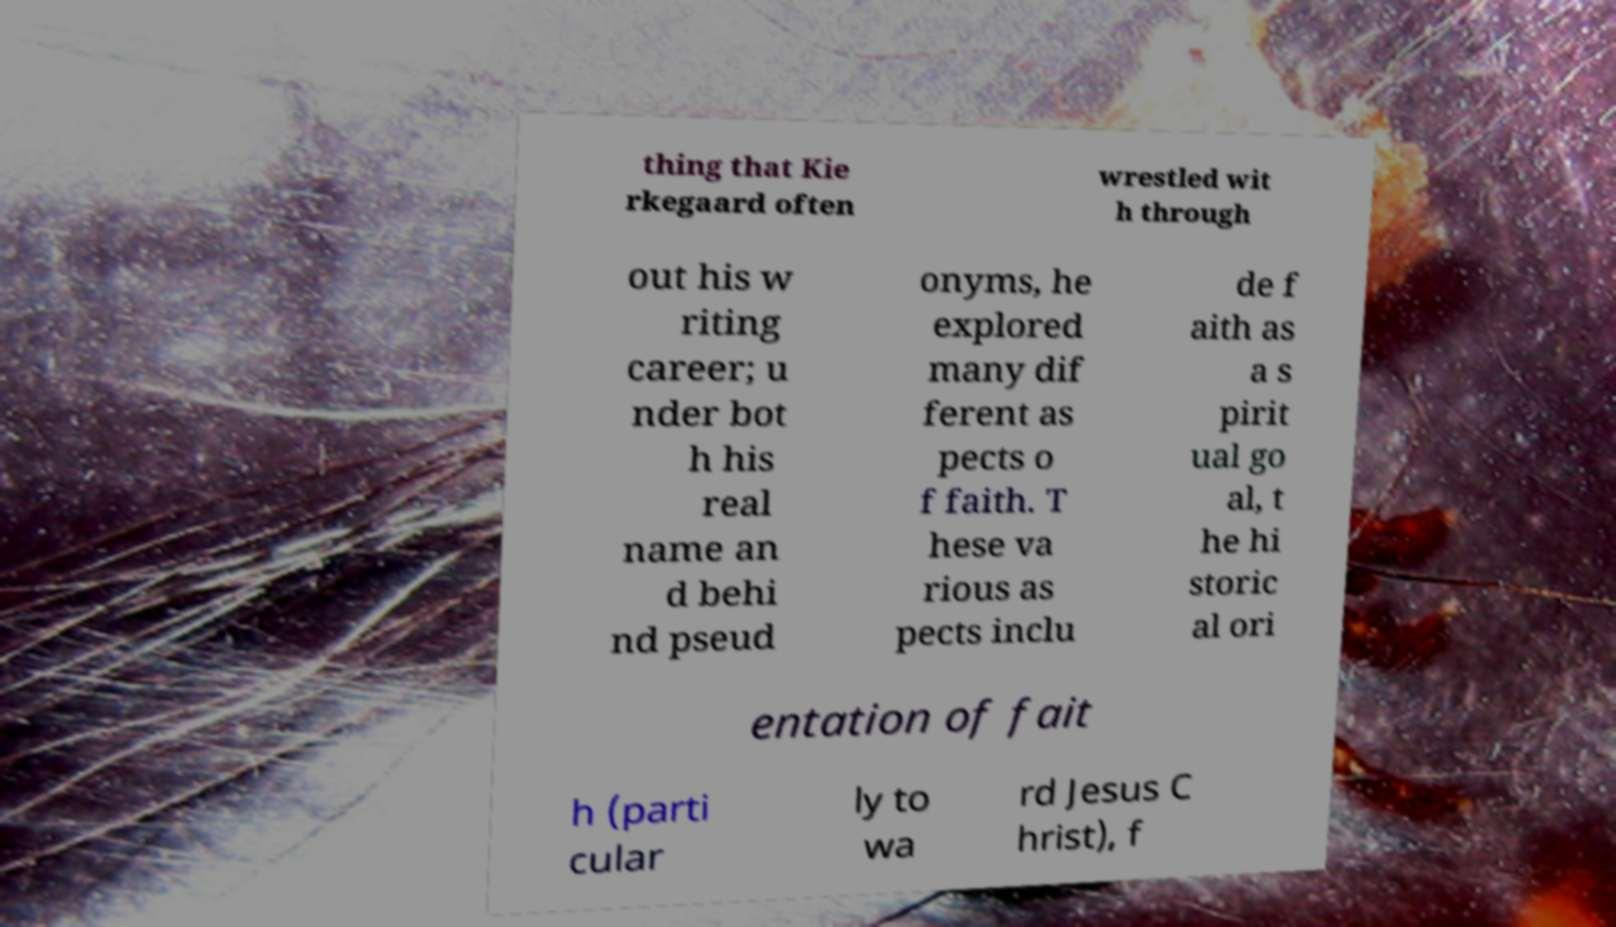Please read and relay the text visible in this image. What does it say? thing that Kie rkegaard often wrestled wit h through out his w riting career; u nder bot h his real name an d behi nd pseud onyms, he explored many dif ferent as pects o f faith. T hese va rious as pects inclu de f aith as a s pirit ual go al, t he hi storic al ori entation of fait h (parti cular ly to wa rd Jesus C hrist), f 